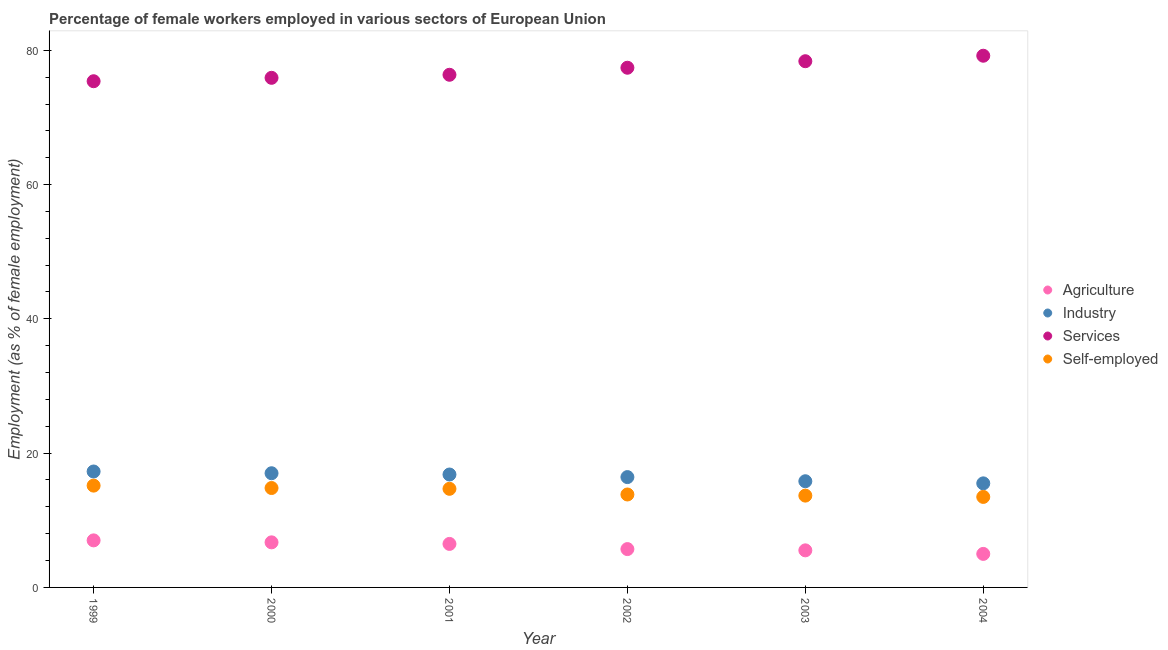How many different coloured dotlines are there?
Offer a very short reply. 4. Is the number of dotlines equal to the number of legend labels?
Your answer should be very brief. Yes. What is the percentage of female workers in industry in 2001?
Your response must be concise. 16.82. Across all years, what is the maximum percentage of female workers in agriculture?
Your answer should be compact. 7.01. Across all years, what is the minimum percentage of female workers in industry?
Ensure brevity in your answer.  15.5. In which year was the percentage of self employed female workers maximum?
Your response must be concise. 1999. In which year was the percentage of female workers in agriculture minimum?
Keep it short and to the point. 2004. What is the total percentage of female workers in industry in the graph?
Provide a succinct answer. 98.84. What is the difference between the percentage of female workers in industry in 2003 and that in 2004?
Your answer should be compact. 0.32. What is the difference between the percentage of female workers in industry in 2003 and the percentage of female workers in services in 2002?
Ensure brevity in your answer.  -61.59. What is the average percentage of female workers in services per year?
Keep it short and to the point. 77.1. In the year 2004, what is the difference between the percentage of female workers in services and percentage of female workers in industry?
Your answer should be compact. 63.69. What is the ratio of the percentage of female workers in services in 2001 to that in 2004?
Provide a succinct answer. 0.96. Is the difference between the percentage of self employed female workers in 2001 and 2003 greater than the difference between the percentage of female workers in agriculture in 2001 and 2003?
Ensure brevity in your answer.  Yes. What is the difference between the highest and the second highest percentage of female workers in agriculture?
Provide a short and direct response. 0.29. What is the difference between the highest and the lowest percentage of female workers in agriculture?
Keep it short and to the point. 2.01. In how many years, is the percentage of female workers in industry greater than the average percentage of female workers in industry taken over all years?
Ensure brevity in your answer.  3. Is the percentage of female workers in industry strictly greater than the percentage of female workers in agriculture over the years?
Offer a very short reply. Yes. Is the percentage of female workers in agriculture strictly less than the percentage of self employed female workers over the years?
Offer a very short reply. Yes. How many dotlines are there?
Keep it short and to the point. 4. Are the values on the major ticks of Y-axis written in scientific E-notation?
Give a very brief answer. No. Does the graph contain any zero values?
Offer a terse response. No. Does the graph contain grids?
Your answer should be very brief. No. How are the legend labels stacked?
Your response must be concise. Vertical. What is the title of the graph?
Provide a succinct answer. Percentage of female workers employed in various sectors of European Union. What is the label or title of the Y-axis?
Provide a short and direct response. Employment (as % of female employment). What is the Employment (as % of female employment) in Agriculture in 1999?
Offer a terse response. 7.01. What is the Employment (as % of female employment) of Industry in 1999?
Give a very brief answer. 17.27. What is the Employment (as % of female employment) of Services in 1999?
Offer a very short reply. 75.39. What is the Employment (as % of female employment) in Self-employed in 1999?
Give a very brief answer. 15.16. What is the Employment (as % of female employment) of Agriculture in 2000?
Offer a very short reply. 6.71. What is the Employment (as % of female employment) of Industry in 2000?
Provide a short and direct response. 17.01. What is the Employment (as % of female employment) in Services in 2000?
Make the answer very short. 75.9. What is the Employment (as % of female employment) of Self-employed in 2000?
Provide a succinct answer. 14.81. What is the Employment (as % of female employment) of Agriculture in 2001?
Your answer should be very brief. 6.48. What is the Employment (as % of female employment) of Industry in 2001?
Give a very brief answer. 16.82. What is the Employment (as % of female employment) of Services in 2001?
Your response must be concise. 76.35. What is the Employment (as % of female employment) of Self-employed in 2001?
Ensure brevity in your answer.  14.69. What is the Employment (as % of female employment) of Agriculture in 2002?
Offer a very short reply. 5.71. What is the Employment (as % of female employment) in Industry in 2002?
Make the answer very short. 16.43. What is the Employment (as % of female employment) of Services in 2002?
Your answer should be very brief. 77.4. What is the Employment (as % of female employment) in Self-employed in 2002?
Your answer should be very brief. 13.84. What is the Employment (as % of female employment) of Agriculture in 2003?
Give a very brief answer. 5.52. What is the Employment (as % of female employment) of Industry in 2003?
Your answer should be compact. 15.82. What is the Employment (as % of female employment) of Services in 2003?
Your response must be concise. 78.37. What is the Employment (as % of female employment) in Self-employed in 2003?
Give a very brief answer. 13.67. What is the Employment (as % of female employment) of Agriculture in 2004?
Make the answer very short. 4.99. What is the Employment (as % of female employment) of Industry in 2004?
Provide a succinct answer. 15.5. What is the Employment (as % of female employment) of Services in 2004?
Ensure brevity in your answer.  79.19. What is the Employment (as % of female employment) of Self-employed in 2004?
Make the answer very short. 13.48. Across all years, what is the maximum Employment (as % of female employment) of Agriculture?
Make the answer very short. 7.01. Across all years, what is the maximum Employment (as % of female employment) in Industry?
Your answer should be very brief. 17.27. Across all years, what is the maximum Employment (as % of female employment) in Services?
Give a very brief answer. 79.19. Across all years, what is the maximum Employment (as % of female employment) of Self-employed?
Keep it short and to the point. 15.16. Across all years, what is the minimum Employment (as % of female employment) in Agriculture?
Keep it short and to the point. 4.99. Across all years, what is the minimum Employment (as % of female employment) of Industry?
Make the answer very short. 15.5. Across all years, what is the minimum Employment (as % of female employment) of Services?
Your answer should be very brief. 75.39. Across all years, what is the minimum Employment (as % of female employment) of Self-employed?
Provide a short and direct response. 13.48. What is the total Employment (as % of female employment) of Agriculture in the graph?
Provide a short and direct response. 36.43. What is the total Employment (as % of female employment) in Industry in the graph?
Make the answer very short. 98.84. What is the total Employment (as % of female employment) of Services in the graph?
Offer a very short reply. 462.61. What is the total Employment (as % of female employment) in Self-employed in the graph?
Offer a terse response. 85.65. What is the difference between the Employment (as % of female employment) of Agriculture in 1999 and that in 2000?
Make the answer very short. 0.29. What is the difference between the Employment (as % of female employment) in Industry in 1999 and that in 2000?
Your answer should be very brief. 0.26. What is the difference between the Employment (as % of female employment) in Services in 1999 and that in 2000?
Keep it short and to the point. -0.51. What is the difference between the Employment (as % of female employment) in Self-employed in 1999 and that in 2000?
Ensure brevity in your answer.  0.36. What is the difference between the Employment (as % of female employment) of Agriculture in 1999 and that in 2001?
Provide a succinct answer. 0.53. What is the difference between the Employment (as % of female employment) in Industry in 1999 and that in 2001?
Give a very brief answer. 0.45. What is the difference between the Employment (as % of female employment) in Services in 1999 and that in 2001?
Give a very brief answer. -0.96. What is the difference between the Employment (as % of female employment) in Self-employed in 1999 and that in 2001?
Provide a succinct answer. 0.48. What is the difference between the Employment (as % of female employment) in Agriculture in 1999 and that in 2002?
Ensure brevity in your answer.  1.3. What is the difference between the Employment (as % of female employment) of Industry in 1999 and that in 2002?
Your answer should be very brief. 0.83. What is the difference between the Employment (as % of female employment) in Services in 1999 and that in 2002?
Your response must be concise. -2.01. What is the difference between the Employment (as % of female employment) in Self-employed in 1999 and that in 2002?
Provide a short and direct response. 1.32. What is the difference between the Employment (as % of female employment) in Agriculture in 1999 and that in 2003?
Offer a terse response. 1.49. What is the difference between the Employment (as % of female employment) of Industry in 1999 and that in 2003?
Provide a short and direct response. 1.45. What is the difference between the Employment (as % of female employment) of Services in 1999 and that in 2003?
Your answer should be compact. -2.98. What is the difference between the Employment (as % of female employment) of Self-employed in 1999 and that in 2003?
Offer a very short reply. 1.49. What is the difference between the Employment (as % of female employment) of Agriculture in 1999 and that in 2004?
Give a very brief answer. 2.01. What is the difference between the Employment (as % of female employment) in Industry in 1999 and that in 2004?
Your response must be concise. 1.77. What is the difference between the Employment (as % of female employment) of Services in 1999 and that in 2004?
Ensure brevity in your answer.  -3.8. What is the difference between the Employment (as % of female employment) in Self-employed in 1999 and that in 2004?
Offer a terse response. 1.68. What is the difference between the Employment (as % of female employment) of Agriculture in 2000 and that in 2001?
Provide a short and direct response. 0.23. What is the difference between the Employment (as % of female employment) of Industry in 2000 and that in 2001?
Provide a succinct answer. 0.19. What is the difference between the Employment (as % of female employment) of Services in 2000 and that in 2001?
Offer a very short reply. -0.45. What is the difference between the Employment (as % of female employment) of Self-employed in 2000 and that in 2001?
Ensure brevity in your answer.  0.12. What is the difference between the Employment (as % of female employment) in Agriculture in 2000 and that in 2002?
Provide a short and direct response. 1. What is the difference between the Employment (as % of female employment) in Industry in 2000 and that in 2002?
Your answer should be compact. 0.57. What is the difference between the Employment (as % of female employment) of Services in 2000 and that in 2002?
Keep it short and to the point. -1.5. What is the difference between the Employment (as % of female employment) in Agriculture in 2000 and that in 2003?
Ensure brevity in your answer.  1.19. What is the difference between the Employment (as % of female employment) in Industry in 2000 and that in 2003?
Give a very brief answer. 1.19. What is the difference between the Employment (as % of female employment) of Services in 2000 and that in 2003?
Provide a short and direct response. -2.47. What is the difference between the Employment (as % of female employment) in Self-employed in 2000 and that in 2003?
Your response must be concise. 1.13. What is the difference between the Employment (as % of female employment) in Agriculture in 2000 and that in 2004?
Ensure brevity in your answer.  1.72. What is the difference between the Employment (as % of female employment) of Industry in 2000 and that in 2004?
Provide a short and direct response. 1.51. What is the difference between the Employment (as % of female employment) of Services in 2000 and that in 2004?
Provide a short and direct response. -3.29. What is the difference between the Employment (as % of female employment) in Self-employed in 2000 and that in 2004?
Make the answer very short. 1.33. What is the difference between the Employment (as % of female employment) of Agriculture in 2001 and that in 2002?
Your response must be concise. 0.77. What is the difference between the Employment (as % of female employment) of Industry in 2001 and that in 2002?
Make the answer very short. 0.38. What is the difference between the Employment (as % of female employment) of Services in 2001 and that in 2002?
Your answer should be compact. -1.05. What is the difference between the Employment (as % of female employment) of Self-employed in 2001 and that in 2002?
Provide a short and direct response. 0.84. What is the difference between the Employment (as % of female employment) of Agriculture in 2001 and that in 2003?
Give a very brief answer. 0.96. What is the difference between the Employment (as % of female employment) in Services in 2001 and that in 2003?
Offer a very short reply. -2.02. What is the difference between the Employment (as % of female employment) in Self-employed in 2001 and that in 2003?
Make the answer very short. 1.01. What is the difference between the Employment (as % of female employment) in Agriculture in 2001 and that in 2004?
Give a very brief answer. 1.49. What is the difference between the Employment (as % of female employment) in Industry in 2001 and that in 2004?
Keep it short and to the point. 1.32. What is the difference between the Employment (as % of female employment) in Services in 2001 and that in 2004?
Your response must be concise. -2.84. What is the difference between the Employment (as % of female employment) of Self-employed in 2001 and that in 2004?
Offer a very short reply. 1.21. What is the difference between the Employment (as % of female employment) of Agriculture in 2002 and that in 2003?
Your answer should be very brief. 0.19. What is the difference between the Employment (as % of female employment) of Industry in 2002 and that in 2003?
Your answer should be very brief. 0.62. What is the difference between the Employment (as % of female employment) in Services in 2002 and that in 2003?
Ensure brevity in your answer.  -0.97. What is the difference between the Employment (as % of female employment) of Self-employed in 2002 and that in 2003?
Provide a succinct answer. 0.17. What is the difference between the Employment (as % of female employment) of Agriculture in 2002 and that in 2004?
Provide a succinct answer. 0.72. What is the difference between the Employment (as % of female employment) of Industry in 2002 and that in 2004?
Give a very brief answer. 0.93. What is the difference between the Employment (as % of female employment) of Services in 2002 and that in 2004?
Offer a very short reply. -1.79. What is the difference between the Employment (as % of female employment) in Self-employed in 2002 and that in 2004?
Offer a very short reply. 0.36. What is the difference between the Employment (as % of female employment) in Agriculture in 2003 and that in 2004?
Give a very brief answer. 0.53. What is the difference between the Employment (as % of female employment) of Industry in 2003 and that in 2004?
Offer a very short reply. 0.32. What is the difference between the Employment (as % of female employment) in Services in 2003 and that in 2004?
Your response must be concise. -0.82. What is the difference between the Employment (as % of female employment) in Self-employed in 2003 and that in 2004?
Offer a very short reply. 0.19. What is the difference between the Employment (as % of female employment) in Agriculture in 1999 and the Employment (as % of female employment) in Industry in 2000?
Your answer should be compact. -10. What is the difference between the Employment (as % of female employment) of Agriculture in 1999 and the Employment (as % of female employment) of Services in 2000?
Your response must be concise. -68.89. What is the difference between the Employment (as % of female employment) of Agriculture in 1999 and the Employment (as % of female employment) of Self-employed in 2000?
Provide a succinct answer. -7.8. What is the difference between the Employment (as % of female employment) in Industry in 1999 and the Employment (as % of female employment) in Services in 2000?
Make the answer very short. -58.63. What is the difference between the Employment (as % of female employment) of Industry in 1999 and the Employment (as % of female employment) of Self-employed in 2000?
Offer a very short reply. 2.46. What is the difference between the Employment (as % of female employment) of Services in 1999 and the Employment (as % of female employment) of Self-employed in 2000?
Offer a terse response. 60.59. What is the difference between the Employment (as % of female employment) of Agriculture in 1999 and the Employment (as % of female employment) of Industry in 2001?
Provide a short and direct response. -9.81. What is the difference between the Employment (as % of female employment) in Agriculture in 1999 and the Employment (as % of female employment) in Services in 2001?
Your response must be concise. -69.35. What is the difference between the Employment (as % of female employment) of Agriculture in 1999 and the Employment (as % of female employment) of Self-employed in 2001?
Ensure brevity in your answer.  -7.68. What is the difference between the Employment (as % of female employment) in Industry in 1999 and the Employment (as % of female employment) in Services in 2001?
Your answer should be very brief. -59.09. What is the difference between the Employment (as % of female employment) in Industry in 1999 and the Employment (as % of female employment) in Self-employed in 2001?
Offer a very short reply. 2.58. What is the difference between the Employment (as % of female employment) of Services in 1999 and the Employment (as % of female employment) of Self-employed in 2001?
Your response must be concise. 60.7. What is the difference between the Employment (as % of female employment) of Agriculture in 1999 and the Employment (as % of female employment) of Industry in 2002?
Ensure brevity in your answer.  -9.43. What is the difference between the Employment (as % of female employment) in Agriculture in 1999 and the Employment (as % of female employment) in Services in 2002?
Your answer should be compact. -70.39. What is the difference between the Employment (as % of female employment) in Agriculture in 1999 and the Employment (as % of female employment) in Self-employed in 2002?
Offer a very short reply. -6.83. What is the difference between the Employment (as % of female employment) in Industry in 1999 and the Employment (as % of female employment) in Services in 2002?
Give a very brief answer. -60.14. What is the difference between the Employment (as % of female employment) of Industry in 1999 and the Employment (as % of female employment) of Self-employed in 2002?
Offer a very short reply. 3.42. What is the difference between the Employment (as % of female employment) in Services in 1999 and the Employment (as % of female employment) in Self-employed in 2002?
Provide a succinct answer. 61.55. What is the difference between the Employment (as % of female employment) of Agriculture in 1999 and the Employment (as % of female employment) of Industry in 2003?
Offer a terse response. -8.81. What is the difference between the Employment (as % of female employment) of Agriculture in 1999 and the Employment (as % of female employment) of Services in 2003?
Offer a terse response. -71.36. What is the difference between the Employment (as % of female employment) of Agriculture in 1999 and the Employment (as % of female employment) of Self-employed in 2003?
Offer a terse response. -6.67. What is the difference between the Employment (as % of female employment) of Industry in 1999 and the Employment (as % of female employment) of Services in 2003?
Make the answer very short. -61.11. What is the difference between the Employment (as % of female employment) of Industry in 1999 and the Employment (as % of female employment) of Self-employed in 2003?
Your response must be concise. 3.59. What is the difference between the Employment (as % of female employment) in Services in 1999 and the Employment (as % of female employment) in Self-employed in 2003?
Offer a very short reply. 61.72. What is the difference between the Employment (as % of female employment) in Agriculture in 1999 and the Employment (as % of female employment) in Industry in 2004?
Give a very brief answer. -8.49. What is the difference between the Employment (as % of female employment) in Agriculture in 1999 and the Employment (as % of female employment) in Services in 2004?
Your answer should be very brief. -72.18. What is the difference between the Employment (as % of female employment) of Agriculture in 1999 and the Employment (as % of female employment) of Self-employed in 2004?
Your answer should be compact. -6.47. What is the difference between the Employment (as % of female employment) in Industry in 1999 and the Employment (as % of female employment) in Services in 2004?
Your answer should be very brief. -61.92. What is the difference between the Employment (as % of female employment) in Industry in 1999 and the Employment (as % of female employment) in Self-employed in 2004?
Give a very brief answer. 3.79. What is the difference between the Employment (as % of female employment) in Services in 1999 and the Employment (as % of female employment) in Self-employed in 2004?
Provide a succinct answer. 61.91. What is the difference between the Employment (as % of female employment) of Agriculture in 2000 and the Employment (as % of female employment) of Industry in 2001?
Offer a terse response. -10.1. What is the difference between the Employment (as % of female employment) in Agriculture in 2000 and the Employment (as % of female employment) in Services in 2001?
Provide a short and direct response. -69.64. What is the difference between the Employment (as % of female employment) of Agriculture in 2000 and the Employment (as % of female employment) of Self-employed in 2001?
Make the answer very short. -7.97. What is the difference between the Employment (as % of female employment) in Industry in 2000 and the Employment (as % of female employment) in Services in 2001?
Make the answer very short. -59.35. What is the difference between the Employment (as % of female employment) in Industry in 2000 and the Employment (as % of female employment) in Self-employed in 2001?
Give a very brief answer. 2.32. What is the difference between the Employment (as % of female employment) in Services in 2000 and the Employment (as % of female employment) in Self-employed in 2001?
Offer a terse response. 61.21. What is the difference between the Employment (as % of female employment) of Agriculture in 2000 and the Employment (as % of female employment) of Industry in 2002?
Provide a succinct answer. -9.72. What is the difference between the Employment (as % of female employment) in Agriculture in 2000 and the Employment (as % of female employment) in Services in 2002?
Offer a terse response. -70.69. What is the difference between the Employment (as % of female employment) of Agriculture in 2000 and the Employment (as % of female employment) of Self-employed in 2002?
Provide a succinct answer. -7.13. What is the difference between the Employment (as % of female employment) of Industry in 2000 and the Employment (as % of female employment) of Services in 2002?
Your response must be concise. -60.4. What is the difference between the Employment (as % of female employment) of Industry in 2000 and the Employment (as % of female employment) of Self-employed in 2002?
Make the answer very short. 3.16. What is the difference between the Employment (as % of female employment) of Services in 2000 and the Employment (as % of female employment) of Self-employed in 2002?
Your answer should be very brief. 62.06. What is the difference between the Employment (as % of female employment) of Agriculture in 2000 and the Employment (as % of female employment) of Industry in 2003?
Make the answer very short. -9.1. What is the difference between the Employment (as % of female employment) in Agriculture in 2000 and the Employment (as % of female employment) in Services in 2003?
Your answer should be compact. -71.66. What is the difference between the Employment (as % of female employment) of Agriculture in 2000 and the Employment (as % of female employment) of Self-employed in 2003?
Provide a succinct answer. -6.96. What is the difference between the Employment (as % of female employment) in Industry in 2000 and the Employment (as % of female employment) in Services in 2003?
Keep it short and to the point. -61.37. What is the difference between the Employment (as % of female employment) of Industry in 2000 and the Employment (as % of female employment) of Self-employed in 2003?
Give a very brief answer. 3.33. What is the difference between the Employment (as % of female employment) in Services in 2000 and the Employment (as % of female employment) in Self-employed in 2003?
Ensure brevity in your answer.  62.22. What is the difference between the Employment (as % of female employment) in Agriculture in 2000 and the Employment (as % of female employment) in Industry in 2004?
Keep it short and to the point. -8.79. What is the difference between the Employment (as % of female employment) of Agriculture in 2000 and the Employment (as % of female employment) of Services in 2004?
Offer a very short reply. -72.47. What is the difference between the Employment (as % of female employment) in Agriculture in 2000 and the Employment (as % of female employment) in Self-employed in 2004?
Offer a very short reply. -6.77. What is the difference between the Employment (as % of female employment) in Industry in 2000 and the Employment (as % of female employment) in Services in 2004?
Provide a short and direct response. -62.18. What is the difference between the Employment (as % of female employment) in Industry in 2000 and the Employment (as % of female employment) in Self-employed in 2004?
Ensure brevity in your answer.  3.53. What is the difference between the Employment (as % of female employment) of Services in 2000 and the Employment (as % of female employment) of Self-employed in 2004?
Your answer should be very brief. 62.42. What is the difference between the Employment (as % of female employment) in Agriculture in 2001 and the Employment (as % of female employment) in Industry in 2002?
Ensure brevity in your answer.  -9.95. What is the difference between the Employment (as % of female employment) in Agriculture in 2001 and the Employment (as % of female employment) in Services in 2002?
Your answer should be compact. -70.92. What is the difference between the Employment (as % of female employment) of Agriculture in 2001 and the Employment (as % of female employment) of Self-employed in 2002?
Provide a short and direct response. -7.36. What is the difference between the Employment (as % of female employment) of Industry in 2001 and the Employment (as % of female employment) of Services in 2002?
Give a very brief answer. -60.58. What is the difference between the Employment (as % of female employment) of Industry in 2001 and the Employment (as % of female employment) of Self-employed in 2002?
Give a very brief answer. 2.97. What is the difference between the Employment (as % of female employment) of Services in 2001 and the Employment (as % of female employment) of Self-employed in 2002?
Make the answer very short. 62.51. What is the difference between the Employment (as % of female employment) of Agriculture in 2001 and the Employment (as % of female employment) of Industry in 2003?
Ensure brevity in your answer.  -9.34. What is the difference between the Employment (as % of female employment) of Agriculture in 2001 and the Employment (as % of female employment) of Services in 2003?
Provide a short and direct response. -71.89. What is the difference between the Employment (as % of female employment) in Agriculture in 2001 and the Employment (as % of female employment) in Self-employed in 2003?
Provide a short and direct response. -7.19. What is the difference between the Employment (as % of female employment) of Industry in 2001 and the Employment (as % of female employment) of Services in 2003?
Ensure brevity in your answer.  -61.56. What is the difference between the Employment (as % of female employment) in Industry in 2001 and the Employment (as % of female employment) in Self-employed in 2003?
Provide a short and direct response. 3.14. What is the difference between the Employment (as % of female employment) of Services in 2001 and the Employment (as % of female employment) of Self-employed in 2003?
Make the answer very short. 62.68. What is the difference between the Employment (as % of female employment) in Agriculture in 2001 and the Employment (as % of female employment) in Industry in 2004?
Your answer should be very brief. -9.02. What is the difference between the Employment (as % of female employment) of Agriculture in 2001 and the Employment (as % of female employment) of Services in 2004?
Your answer should be compact. -72.71. What is the difference between the Employment (as % of female employment) of Agriculture in 2001 and the Employment (as % of female employment) of Self-employed in 2004?
Your response must be concise. -7. What is the difference between the Employment (as % of female employment) of Industry in 2001 and the Employment (as % of female employment) of Services in 2004?
Offer a terse response. -62.37. What is the difference between the Employment (as % of female employment) of Industry in 2001 and the Employment (as % of female employment) of Self-employed in 2004?
Keep it short and to the point. 3.34. What is the difference between the Employment (as % of female employment) in Services in 2001 and the Employment (as % of female employment) in Self-employed in 2004?
Make the answer very short. 62.87. What is the difference between the Employment (as % of female employment) of Agriculture in 2002 and the Employment (as % of female employment) of Industry in 2003?
Keep it short and to the point. -10.11. What is the difference between the Employment (as % of female employment) of Agriculture in 2002 and the Employment (as % of female employment) of Services in 2003?
Provide a succinct answer. -72.66. What is the difference between the Employment (as % of female employment) in Agriculture in 2002 and the Employment (as % of female employment) in Self-employed in 2003?
Your answer should be compact. -7.96. What is the difference between the Employment (as % of female employment) of Industry in 2002 and the Employment (as % of female employment) of Services in 2003?
Your answer should be very brief. -61.94. What is the difference between the Employment (as % of female employment) in Industry in 2002 and the Employment (as % of female employment) in Self-employed in 2003?
Provide a succinct answer. 2.76. What is the difference between the Employment (as % of female employment) in Services in 2002 and the Employment (as % of female employment) in Self-employed in 2003?
Provide a succinct answer. 63.73. What is the difference between the Employment (as % of female employment) of Agriculture in 2002 and the Employment (as % of female employment) of Industry in 2004?
Offer a very short reply. -9.79. What is the difference between the Employment (as % of female employment) in Agriculture in 2002 and the Employment (as % of female employment) in Services in 2004?
Keep it short and to the point. -73.48. What is the difference between the Employment (as % of female employment) in Agriculture in 2002 and the Employment (as % of female employment) in Self-employed in 2004?
Offer a terse response. -7.77. What is the difference between the Employment (as % of female employment) of Industry in 2002 and the Employment (as % of female employment) of Services in 2004?
Ensure brevity in your answer.  -62.76. What is the difference between the Employment (as % of female employment) of Industry in 2002 and the Employment (as % of female employment) of Self-employed in 2004?
Offer a very short reply. 2.95. What is the difference between the Employment (as % of female employment) in Services in 2002 and the Employment (as % of female employment) in Self-employed in 2004?
Provide a short and direct response. 63.92. What is the difference between the Employment (as % of female employment) of Agriculture in 2003 and the Employment (as % of female employment) of Industry in 2004?
Offer a terse response. -9.98. What is the difference between the Employment (as % of female employment) in Agriculture in 2003 and the Employment (as % of female employment) in Services in 2004?
Make the answer very short. -73.67. What is the difference between the Employment (as % of female employment) of Agriculture in 2003 and the Employment (as % of female employment) of Self-employed in 2004?
Your answer should be very brief. -7.96. What is the difference between the Employment (as % of female employment) in Industry in 2003 and the Employment (as % of female employment) in Services in 2004?
Ensure brevity in your answer.  -63.37. What is the difference between the Employment (as % of female employment) in Industry in 2003 and the Employment (as % of female employment) in Self-employed in 2004?
Provide a short and direct response. 2.34. What is the difference between the Employment (as % of female employment) in Services in 2003 and the Employment (as % of female employment) in Self-employed in 2004?
Provide a succinct answer. 64.89. What is the average Employment (as % of female employment) of Agriculture per year?
Your answer should be compact. 6.07. What is the average Employment (as % of female employment) of Industry per year?
Offer a very short reply. 16.47. What is the average Employment (as % of female employment) of Services per year?
Offer a terse response. 77.1. What is the average Employment (as % of female employment) of Self-employed per year?
Your answer should be compact. 14.28. In the year 1999, what is the difference between the Employment (as % of female employment) in Agriculture and Employment (as % of female employment) in Industry?
Offer a terse response. -10.26. In the year 1999, what is the difference between the Employment (as % of female employment) in Agriculture and Employment (as % of female employment) in Services?
Your response must be concise. -68.38. In the year 1999, what is the difference between the Employment (as % of female employment) in Agriculture and Employment (as % of female employment) in Self-employed?
Offer a very short reply. -8.16. In the year 1999, what is the difference between the Employment (as % of female employment) of Industry and Employment (as % of female employment) of Services?
Your answer should be compact. -58.13. In the year 1999, what is the difference between the Employment (as % of female employment) in Industry and Employment (as % of female employment) in Self-employed?
Ensure brevity in your answer.  2.1. In the year 1999, what is the difference between the Employment (as % of female employment) in Services and Employment (as % of female employment) in Self-employed?
Provide a short and direct response. 60.23. In the year 2000, what is the difference between the Employment (as % of female employment) of Agriculture and Employment (as % of female employment) of Industry?
Your response must be concise. -10.29. In the year 2000, what is the difference between the Employment (as % of female employment) of Agriculture and Employment (as % of female employment) of Services?
Offer a very short reply. -69.18. In the year 2000, what is the difference between the Employment (as % of female employment) in Agriculture and Employment (as % of female employment) in Self-employed?
Offer a very short reply. -8.09. In the year 2000, what is the difference between the Employment (as % of female employment) in Industry and Employment (as % of female employment) in Services?
Your response must be concise. -58.89. In the year 2000, what is the difference between the Employment (as % of female employment) of Industry and Employment (as % of female employment) of Self-employed?
Keep it short and to the point. 2.2. In the year 2000, what is the difference between the Employment (as % of female employment) in Services and Employment (as % of female employment) in Self-employed?
Offer a terse response. 61.09. In the year 2001, what is the difference between the Employment (as % of female employment) of Agriculture and Employment (as % of female employment) of Industry?
Ensure brevity in your answer.  -10.34. In the year 2001, what is the difference between the Employment (as % of female employment) of Agriculture and Employment (as % of female employment) of Services?
Provide a short and direct response. -69.87. In the year 2001, what is the difference between the Employment (as % of female employment) in Agriculture and Employment (as % of female employment) in Self-employed?
Provide a succinct answer. -8.21. In the year 2001, what is the difference between the Employment (as % of female employment) in Industry and Employment (as % of female employment) in Services?
Provide a succinct answer. -59.54. In the year 2001, what is the difference between the Employment (as % of female employment) in Industry and Employment (as % of female employment) in Self-employed?
Ensure brevity in your answer.  2.13. In the year 2001, what is the difference between the Employment (as % of female employment) in Services and Employment (as % of female employment) in Self-employed?
Your response must be concise. 61.67. In the year 2002, what is the difference between the Employment (as % of female employment) in Agriculture and Employment (as % of female employment) in Industry?
Offer a terse response. -10.72. In the year 2002, what is the difference between the Employment (as % of female employment) in Agriculture and Employment (as % of female employment) in Services?
Your answer should be very brief. -71.69. In the year 2002, what is the difference between the Employment (as % of female employment) of Agriculture and Employment (as % of female employment) of Self-employed?
Your answer should be very brief. -8.13. In the year 2002, what is the difference between the Employment (as % of female employment) in Industry and Employment (as % of female employment) in Services?
Your answer should be very brief. -60.97. In the year 2002, what is the difference between the Employment (as % of female employment) in Industry and Employment (as % of female employment) in Self-employed?
Offer a very short reply. 2.59. In the year 2002, what is the difference between the Employment (as % of female employment) in Services and Employment (as % of female employment) in Self-employed?
Keep it short and to the point. 63.56. In the year 2003, what is the difference between the Employment (as % of female employment) in Agriculture and Employment (as % of female employment) in Industry?
Your response must be concise. -10.29. In the year 2003, what is the difference between the Employment (as % of female employment) in Agriculture and Employment (as % of female employment) in Services?
Provide a short and direct response. -72.85. In the year 2003, what is the difference between the Employment (as % of female employment) in Agriculture and Employment (as % of female employment) in Self-employed?
Offer a terse response. -8.15. In the year 2003, what is the difference between the Employment (as % of female employment) of Industry and Employment (as % of female employment) of Services?
Your answer should be compact. -62.56. In the year 2003, what is the difference between the Employment (as % of female employment) of Industry and Employment (as % of female employment) of Self-employed?
Offer a terse response. 2.14. In the year 2003, what is the difference between the Employment (as % of female employment) in Services and Employment (as % of female employment) in Self-employed?
Offer a terse response. 64.7. In the year 2004, what is the difference between the Employment (as % of female employment) in Agriculture and Employment (as % of female employment) in Industry?
Your answer should be compact. -10.51. In the year 2004, what is the difference between the Employment (as % of female employment) in Agriculture and Employment (as % of female employment) in Services?
Ensure brevity in your answer.  -74.2. In the year 2004, what is the difference between the Employment (as % of female employment) in Agriculture and Employment (as % of female employment) in Self-employed?
Your answer should be compact. -8.49. In the year 2004, what is the difference between the Employment (as % of female employment) in Industry and Employment (as % of female employment) in Services?
Ensure brevity in your answer.  -63.69. In the year 2004, what is the difference between the Employment (as % of female employment) of Industry and Employment (as % of female employment) of Self-employed?
Your response must be concise. 2.02. In the year 2004, what is the difference between the Employment (as % of female employment) of Services and Employment (as % of female employment) of Self-employed?
Make the answer very short. 65.71. What is the ratio of the Employment (as % of female employment) in Agriculture in 1999 to that in 2000?
Ensure brevity in your answer.  1.04. What is the ratio of the Employment (as % of female employment) of Industry in 1999 to that in 2000?
Make the answer very short. 1.02. What is the ratio of the Employment (as % of female employment) of Self-employed in 1999 to that in 2000?
Ensure brevity in your answer.  1.02. What is the ratio of the Employment (as % of female employment) of Agriculture in 1999 to that in 2001?
Offer a very short reply. 1.08. What is the ratio of the Employment (as % of female employment) in Industry in 1999 to that in 2001?
Offer a very short reply. 1.03. What is the ratio of the Employment (as % of female employment) of Services in 1999 to that in 2001?
Offer a very short reply. 0.99. What is the ratio of the Employment (as % of female employment) of Self-employed in 1999 to that in 2001?
Your answer should be compact. 1.03. What is the ratio of the Employment (as % of female employment) in Agriculture in 1999 to that in 2002?
Provide a succinct answer. 1.23. What is the ratio of the Employment (as % of female employment) in Industry in 1999 to that in 2002?
Give a very brief answer. 1.05. What is the ratio of the Employment (as % of female employment) of Services in 1999 to that in 2002?
Offer a terse response. 0.97. What is the ratio of the Employment (as % of female employment) of Self-employed in 1999 to that in 2002?
Your answer should be very brief. 1.1. What is the ratio of the Employment (as % of female employment) in Agriculture in 1999 to that in 2003?
Your answer should be very brief. 1.27. What is the ratio of the Employment (as % of female employment) in Industry in 1999 to that in 2003?
Give a very brief answer. 1.09. What is the ratio of the Employment (as % of female employment) of Self-employed in 1999 to that in 2003?
Give a very brief answer. 1.11. What is the ratio of the Employment (as % of female employment) in Agriculture in 1999 to that in 2004?
Your response must be concise. 1.4. What is the ratio of the Employment (as % of female employment) in Industry in 1999 to that in 2004?
Give a very brief answer. 1.11. What is the ratio of the Employment (as % of female employment) of Self-employed in 1999 to that in 2004?
Your response must be concise. 1.12. What is the ratio of the Employment (as % of female employment) of Agriculture in 2000 to that in 2001?
Offer a terse response. 1.04. What is the ratio of the Employment (as % of female employment) of Industry in 2000 to that in 2001?
Offer a terse response. 1.01. What is the ratio of the Employment (as % of female employment) in Services in 2000 to that in 2001?
Your answer should be very brief. 0.99. What is the ratio of the Employment (as % of female employment) of Agriculture in 2000 to that in 2002?
Your response must be concise. 1.18. What is the ratio of the Employment (as % of female employment) in Industry in 2000 to that in 2002?
Offer a terse response. 1.03. What is the ratio of the Employment (as % of female employment) in Services in 2000 to that in 2002?
Your response must be concise. 0.98. What is the ratio of the Employment (as % of female employment) in Self-employed in 2000 to that in 2002?
Give a very brief answer. 1.07. What is the ratio of the Employment (as % of female employment) of Agriculture in 2000 to that in 2003?
Offer a very short reply. 1.22. What is the ratio of the Employment (as % of female employment) in Industry in 2000 to that in 2003?
Keep it short and to the point. 1.08. What is the ratio of the Employment (as % of female employment) of Services in 2000 to that in 2003?
Your answer should be very brief. 0.97. What is the ratio of the Employment (as % of female employment) in Self-employed in 2000 to that in 2003?
Offer a very short reply. 1.08. What is the ratio of the Employment (as % of female employment) of Agriculture in 2000 to that in 2004?
Give a very brief answer. 1.34. What is the ratio of the Employment (as % of female employment) in Industry in 2000 to that in 2004?
Offer a terse response. 1.1. What is the ratio of the Employment (as % of female employment) in Services in 2000 to that in 2004?
Provide a short and direct response. 0.96. What is the ratio of the Employment (as % of female employment) in Self-employed in 2000 to that in 2004?
Your response must be concise. 1.1. What is the ratio of the Employment (as % of female employment) in Agriculture in 2001 to that in 2002?
Offer a terse response. 1.13. What is the ratio of the Employment (as % of female employment) in Industry in 2001 to that in 2002?
Provide a short and direct response. 1.02. What is the ratio of the Employment (as % of female employment) in Services in 2001 to that in 2002?
Your response must be concise. 0.99. What is the ratio of the Employment (as % of female employment) in Self-employed in 2001 to that in 2002?
Your response must be concise. 1.06. What is the ratio of the Employment (as % of female employment) of Agriculture in 2001 to that in 2003?
Offer a terse response. 1.17. What is the ratio of the Employment (as % of female employment) in Industry in 2001 to that in 2003?
Make the answer very short. 1.06. What is the ratio of the Employment (as % of female employment) of Services in 2001 to that in 2003?
Your response must be concise. 0.97. What is the ratio of the Employment (as % of female employment) in Self-employed in 2001 to that in 2003?
Give a very brief answer. 1.07. What is the ratio of the Employment (as % of female employment) of Agriculture in 2001 to that in 2004?
Offer a terse response. 1.3. What is the ratio of the Employment (as % of female employment) of Industry in 2001 to that in 2004?
Offer a terse response. 1.08. What is the ratio of the Employment (as % of female employment) in Services in 2001 to that in 2004?
Offer a very short reply. 0.96. What is the ratio of the Employment (as % of female employment) of Self-employed in 2001 to that in 2004?
Offer a very short reply. 1.09. What is the ratio of the Employment (as % of female employment) of Agriculture in 2002 to that in 2003?
Offer a terse response. 1.03. What is the ratio of the Employment (as % of female employment) in Industry in 2002 to that in 2003?
Your response must be concise. 1.04. What is the ratio of the Employment (as % of female employment) of Services in 2002 to that in 2003?
Your answer should be compact. 0.99. What is the ratio of the Employment (as % of female employment) in Self-employed in 2002 to that in 2003?
Provide a succinct answer. 1.01. What is the ratio of the Employment (as % of female employment) in Agriculture in 2002 to that in 2004?
Ensure brevity in your answer.  1.14. What is the ratio of the Employment (as % of female employment) in Industry in 2002 to that in 2004?
Give a very brief answer. 1.06. What is the ratio of the Employment (as % of female employment) in Services in 2002 to that in 2004?
Keep it short and to the point. 0.98. What is the ratio of the Employment (as % of female employment) in Self-employed in 2002 to that in 2004?
Make the answer very short. 1.03. What is the ratio of the Employment (as % of female employment) in Agriculture in 2003 to that in 2004?
Provide a short and direct response. 1.11. What is the ratio of the Employment (as % of female employment) of Industry in 2003 to that in 2004?
Keep it short and to the point. 1.02. What is the ratio of the Employment (as % of female employment) in Services in 2003 to that in 2004?
Provide a succinct answer. 0.99. What is the ratio of the Employment (as % of female employment) in Self-employed in 2003 to that in 2004?
Ensure brevity in your answer.  1.01. What is the difference between the highest and the second highest Employment (as % of female employment) in Agriculture?
Offer a very short reply. 0.29. What is the difference between the highest and the second highest Employment (as % of female employment) in Industry?
Provide a succinct answer. 0.26. What is the difference between the highest and the second highest Employment (as % of female employment) of Services?
Provide a short and direct response. 0.82. What is the difference between the highest and the second highest Employment (as % of female employment) in Self-employed?
Offer a very short reply. 0.36. What is the difference between the highest and the lowest Employment (as % of female employment) of Agriculture?
Keep it short and to the point. 2.01. What is the difference between the highest and the lowest Employment (as % of female employment) in Industry?
Your answer should be compact. 1.77. What is the difference between the highest and the lowest Employment (as % of female employment) in Services?
Provide a short and direct response. 3.8. What is the difference between the highest and the lowest Employment (as % of female employment) in Self-employed?
Your answer should be compact. 1.68. 